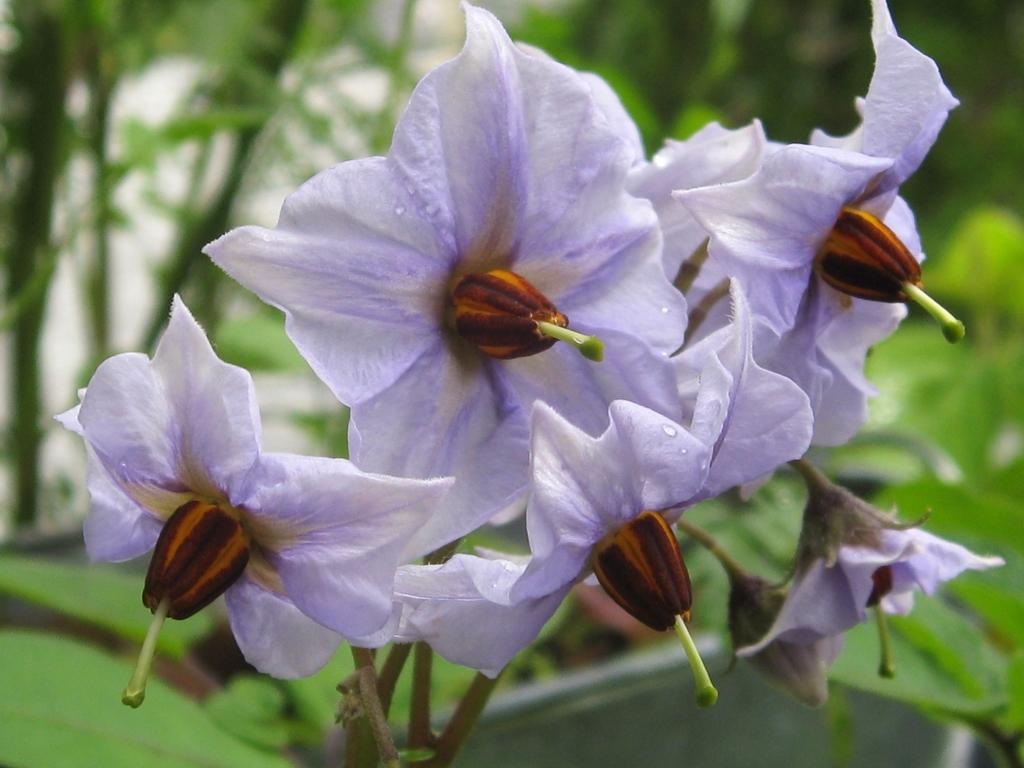What type of plants can be seen in the image? There are flowers in the image. What color is predominant in the background of the image? The background of the image is green. What type of beds are visible in the image? There are no beds present in the image; it features flowers and a green background. 